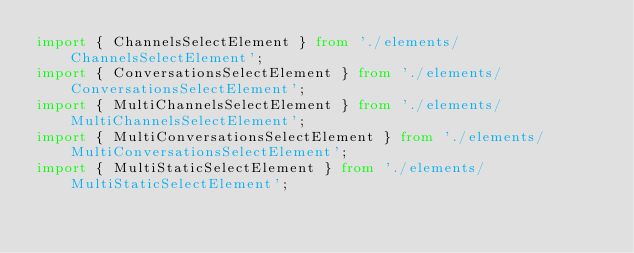<code> <loc_0><loc_0><loc_500><loc_500><_TypeScript_>import { ChannelsSelectElement } from './elements/ChannelsSelectElement';
import { ConversationsSelectElement } from './elements/ConversationsSelectElement';
import { MultiChannelsSelectElement } from './elements/MultiChannelsSelectElement';
import { MultiConversationsSelectElement } from './elements/MultiConversationsSelectElement';
import { MultiStaticSelectElement } from './elements/MultiStaticSelectElement';</code> 